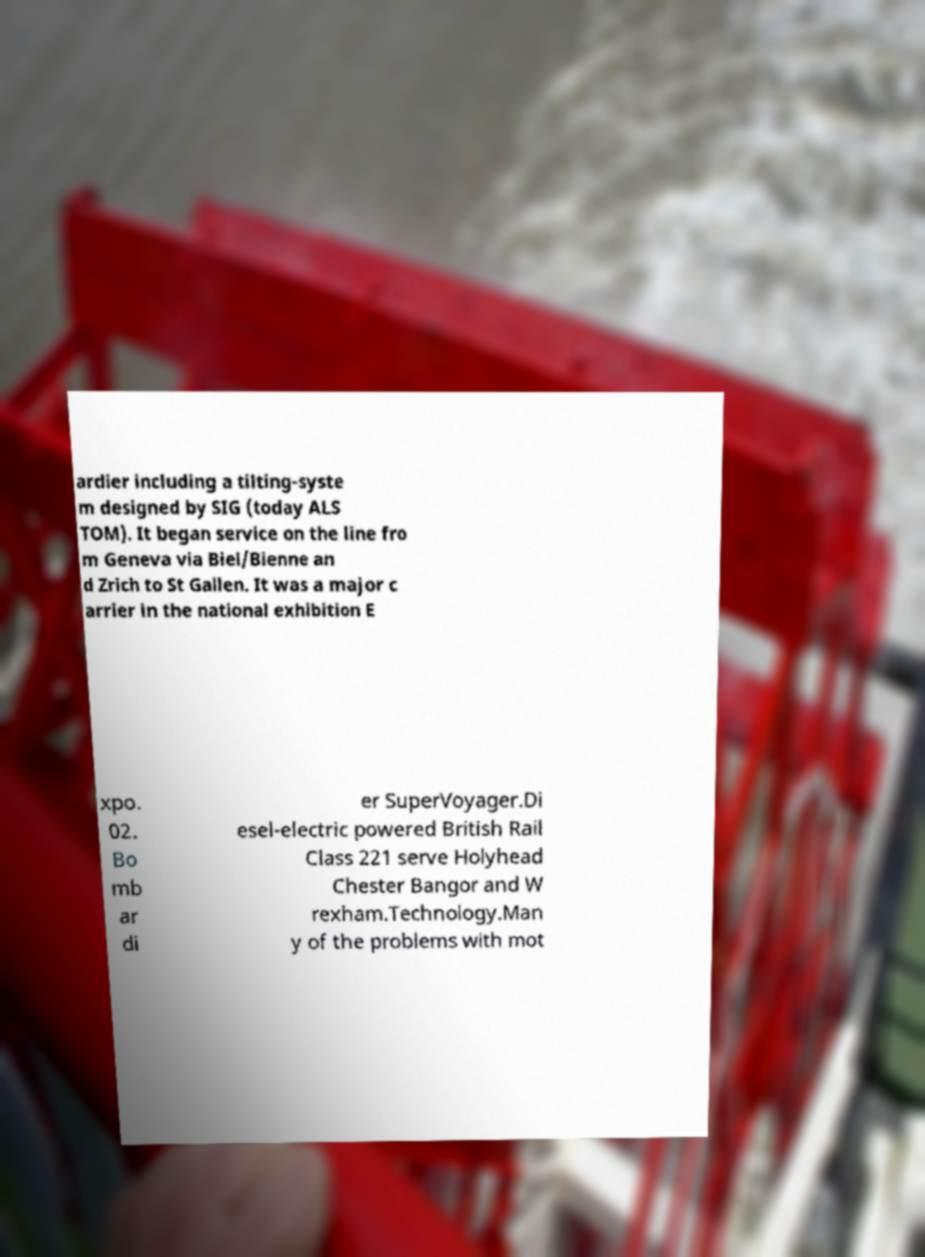There's text embedded in this image that I need extracted. Can you transcribe it verbatim? ardier including a tilting-syste m designed by SIG (today ALS TOM). It began service on the line fro m Geneva via Biel/Bienne an d Zrich to St Gallen. It was a major c arrier in the national exhibition E xpo. 02. Bo mb ar di er SuperVoyager.Di esel-electric powered British Rail Class 221 serve Holyhead Chester Bangor and W rexham.Technology.Man y of the problems with mot 